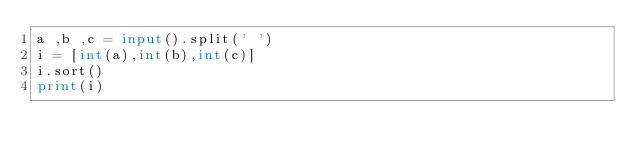Convert code to text. <code><loc_0><loc_0><loc_500><loc_500><_Python_>a ,b ,c = input().split(' ')
i = [int(a),int(b),int(c)]
i.sort()
print(i)</code> 